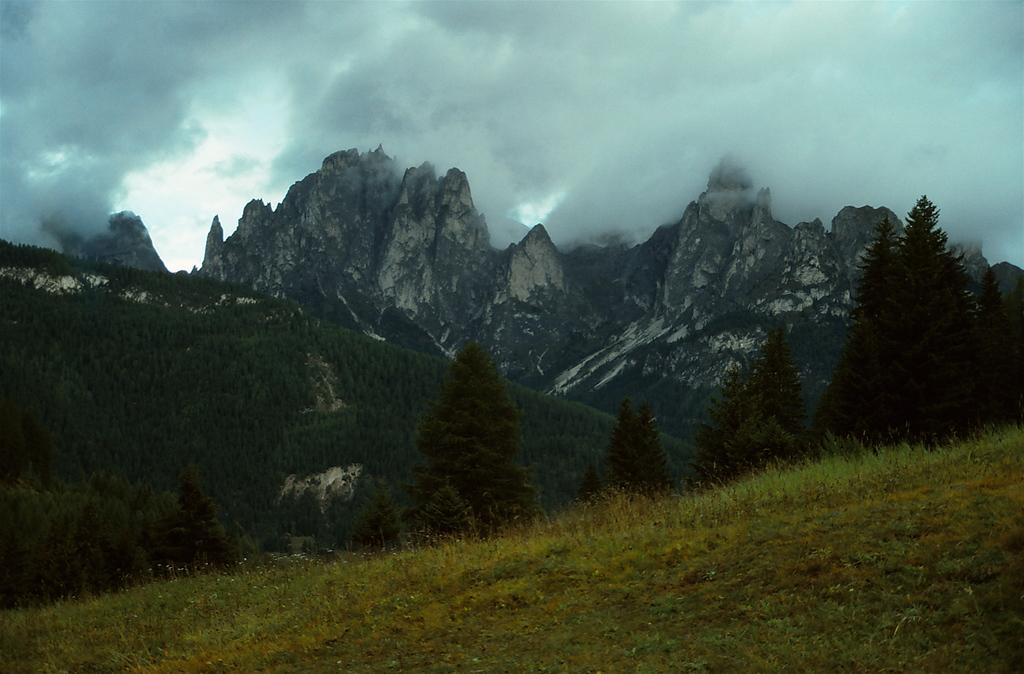What type of vegetation is present in the image? There is grass in the image. What other natural elements can be seen in the image? There are trees in the image. What can be seen in the distance in the image? There are mountains in the background of the image. How would you describe the sky in the image? The sky is cloudy in the background of the image. What type of pleasure can be seen enjoying the coast in the image? There is no coast or pleasure visible in the image; it features grass, trees, mountains, and a cloudy sky. 